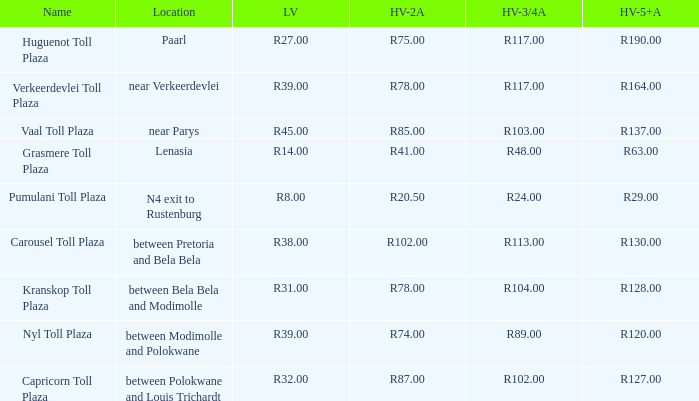What is the location of the Carousel toll plaza? Between pretoria and bela bela. 